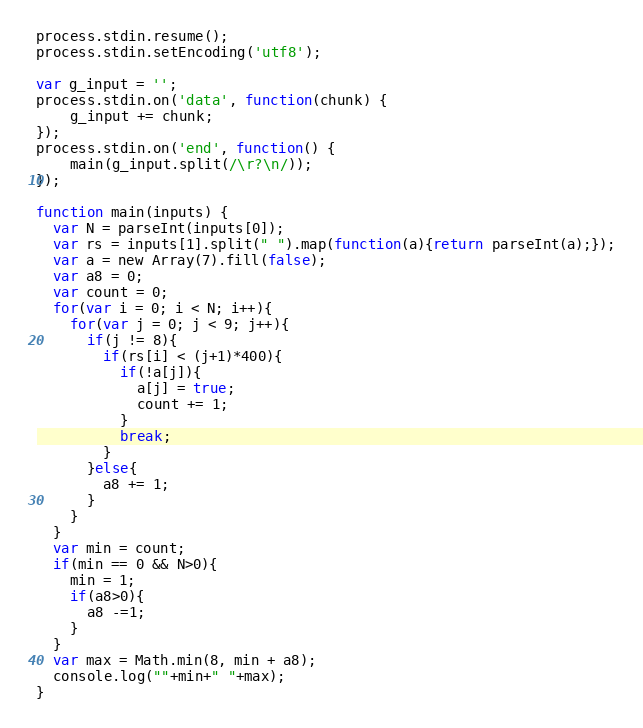Convert code to text. <code><loc_0><loc_0><loc_500><loc_500><_JavaScript_>process.stdin.resume();
process.stdin.setEncoding('utf8');

var g_input = '';
process.stdin.on('data', function(chunk) {
    g_input += chunk;
});
process.stdin.on('end', function() {
    main(g_input.split(/\r?\n/));
});

function main(inputs) {
  var N = parseInt(inputs[0]);
  var rs = inputs[1].split(" ").map(function(a){return parseInt(a);});
  var a = new Array(7).fill(false);
  var a8 = 0;
  var count = 0;
  for(var i = 0; i < N; i++){
    for(var j = 0; j < 9; j++){
      if(j != 8){
        if(rs[i] < (j+1)*400){
          if(!a[j]){
            a[j] = true;
            count += 1;
          }
          break;
        }
      }else{
        a8 += 1;
      }
    }
  }
  var min = count;
  if(min == 0 && N>0){
    min = 1;
    if(a8>0){
      a8 -=1;
    }
  }
  var max = Math.min(8, min + a8);
  console.log(""+min+" "+max);
}
</code> 